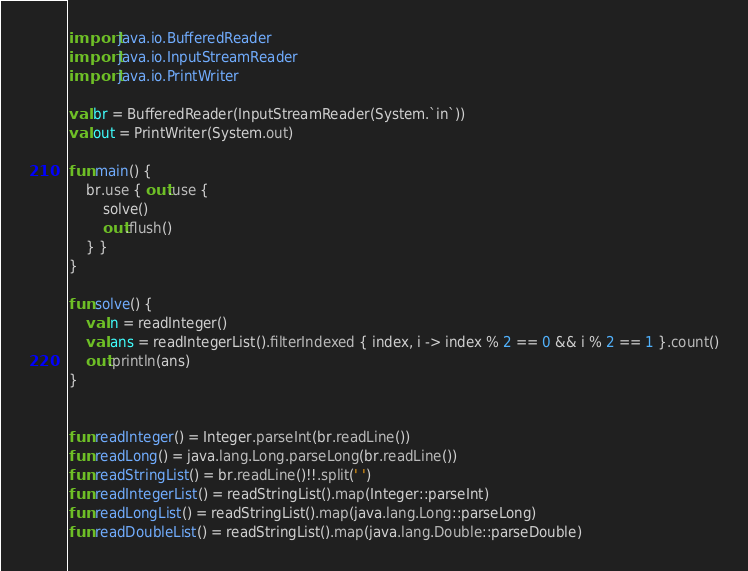<code> <loc_0><loc_0><loc_500><loc_500><_Kotlin_>import java.io.BufferedReader
import java.io.InputStreamReader
import java.io.PrintWriter

val br = BufferedReader(InputStreamReader(System.`in`))
val out = PrintWriter(System.out)

fun main() {
    br.use { out.use {
        solve()
        out.flush()
    } }
}

fun solve() {
    val n = readInteger()
    val ans = readIntegerList().filterIndexed { index, i -> index % 2 == 0 && i % 2 == 1 }.count()
    out.println(ans)
}


fun readInteger() = Integer.parseInt(br.readLine())
fun readLong() = java.lang.Long.parseLong(br.readLine())
fun readStringList() = br.readLine()!!.split(' ')
fun readIntegerList() = readStringList().map(Integer::parseInt)
fun readLongList() = readStringList().map(java.lang.Long::parseLong)
fun readDoubleList() = readStringList().map(java.lang.Double::parseDouble)
</code> 